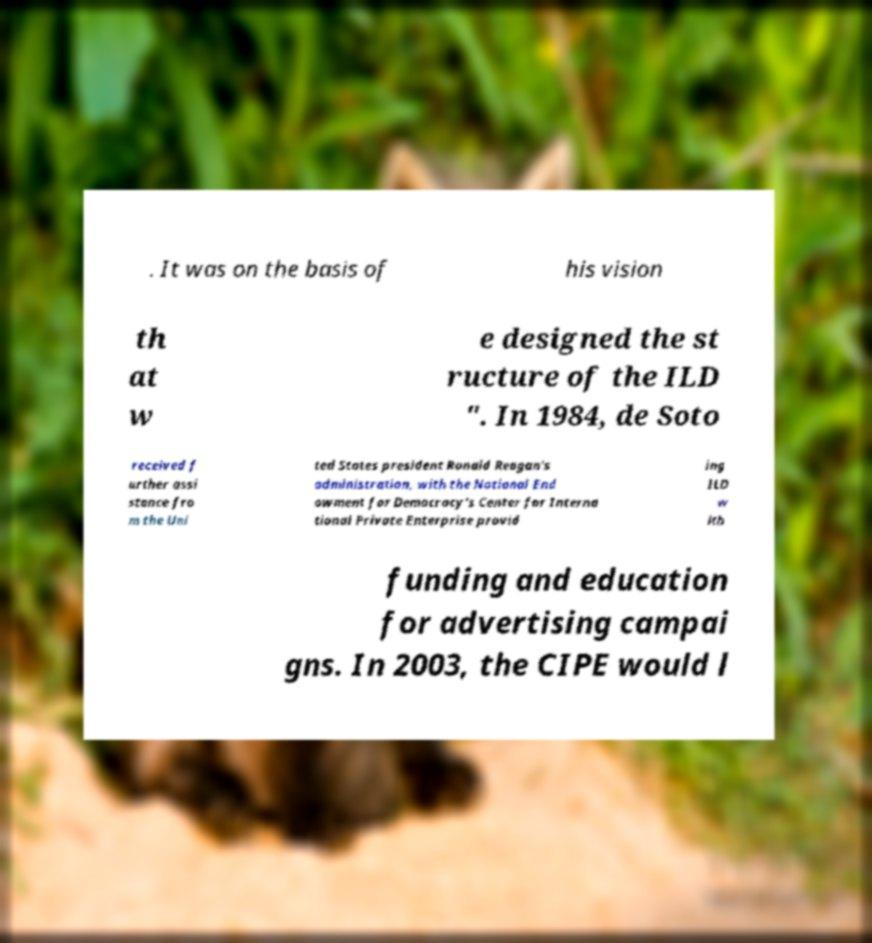Could you assist in decoding the text presented in this image and type it out clearly? . It was on the basis of his vision th at w e designed the st ructure of the ILD ". In 1984, de Soto received f urther assi stance fro m the Uni ted States president Ronald Reagan's administration, with the National End owment for Democracy's Center for Interna tional Private Enterprise provid ing ILD w ith funding and education for advertising campai gns. In 2003, the CIPE would l 